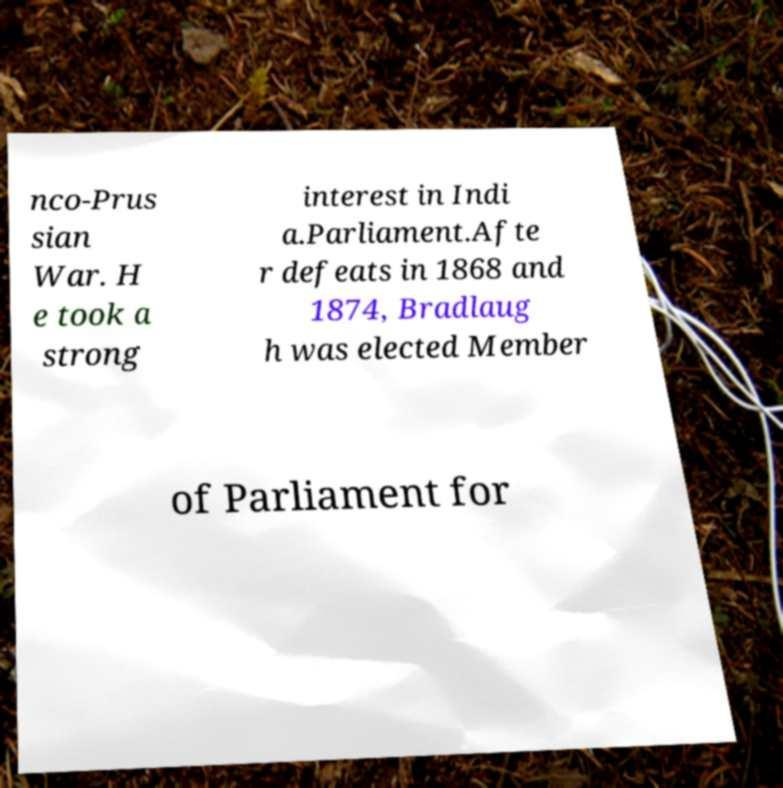There's text embedded in this image that I need extracted. Can you transcribe it verbatim? nco-Prus sian War. H e took a strong interest in Indi a.Parliament.Afte r defeats in 1868 and 1874, Bradlaug h was elected Member of Parliament for 